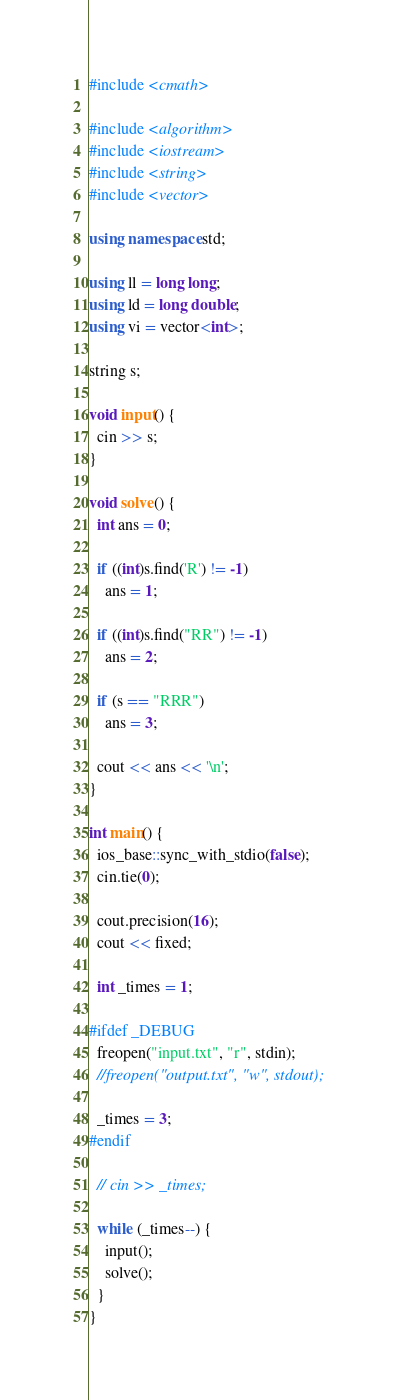Convert code to text. <code><loc_0><loc_0><loc_500><loc_500><_C++_>#include <cmath>

#include <algorithm>
#include <iostream>
#include <string>
#include <vector>

using namespace std;

using ll = long long;
using ld = long double;
using vi = vector<int>;

string s;

void input() {
  cin >> s;
}

void solve() {
  int ans = 0;

  if ((int)s.find('R') != -1)
    ans = 1;

  if ((int)s.find("RR") != -1)
    ans = 2;

  if (s == "RRR")
    ans = 3;

  cout << ans << '\n';
}

int main() {
  ios_base::sync_with_stdio(false);
  cin.tie(0);

  cout.precision(16);
  cout << fixed;

  int _times = 1;

#ifdef _DEBUG
  freopen("input.txt", "r", stdin);
  //freopen("output.txt", "w", stdout);

  _times = 3;
#endif

  // cin >> _times;

  while (_times--) {
    input();
    solve();
  }
}
</code> 